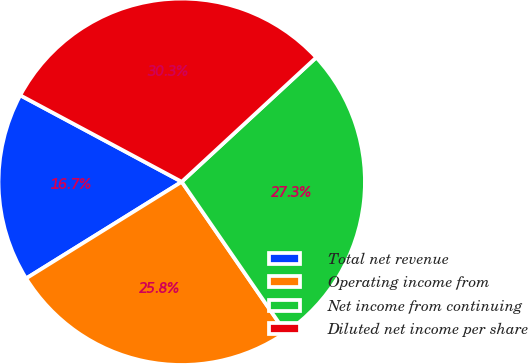Convert chart to OTSL. <chart><loc_0><loc_0><loc_500><loc_500><pie_chart><fcel>Total net revenue<fcel>Operating income from<fcel>Net income from continuing<fcel>Diluted net income per share<nl><fcel>16.67%<fcel>25.76%<fcel>27.27%<fcel>30.3%<nl></chart> 